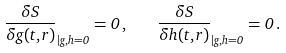Convert formula to latex. <formula><loc_0><loc_0><loc_500><loc_500>\frac { \delta S } { \delta g ( t , r ) } _ { | g , h = 0 } = 0 \, , \quad \frac { \delta S } { \delta h ( t , r ) } _ { | g , h = 0 } = 0 \, .</formula> 